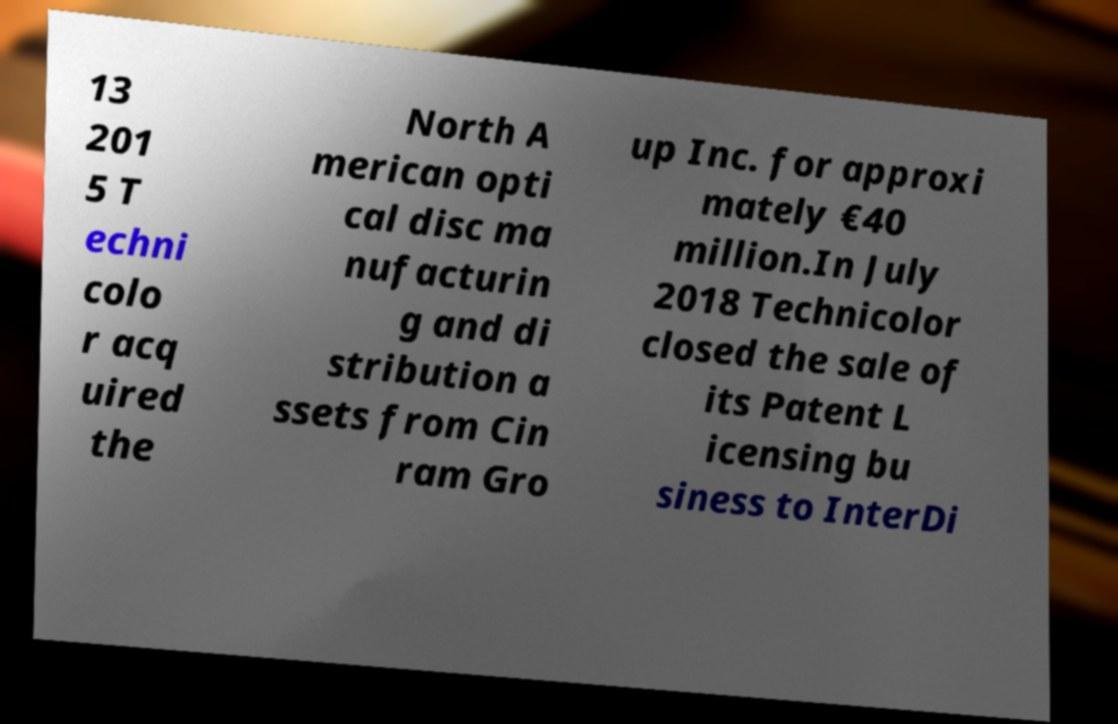For documentation purposes, I need the text within this image transcribed. Could you provide that? 13 201 5 T echni colo r acq uired the North A merican opti cal disc ma nufacturin g and di stribution a ssets from Cin ram Gro up Inc. for approxi mately €40 million.In July 2018 Technicolor closed the sale of its Patent L icensing bu siness to InterDi 